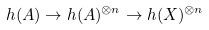Convert formula to latex. <formula><loc_0><loc_0><loc_500><loc_500>h ( A ) \to h ( A ) ^ { \otimes n } \to h ( X ) ^ { \otimes n }</formula> 